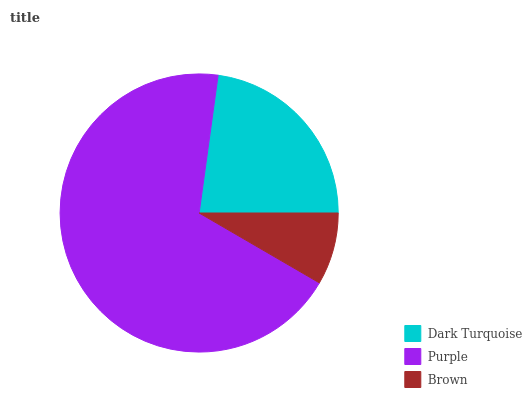Is Brown the minimum?
Answer yes or no. Yes. Is Purple the maximum?
Answer yes or no. Yes. Is Purple the minimum?
Answer yes or no. No. Is Brown the maximum?
Answer yes or no. No. Is Purple greater than Brown?
Answer yes or no. Yes. Is Brown less than Purple?
Answer yes or no. Yes. Is Brown greater than Purple?
Answer yes or no. No. Is Purple less than Brown?
Answer yes or no. No. Is Dark Turquoise the high median?
Answer yes or no. Yes. Is Dark Turquoise the low median?
Answer yes or no. Yes. Is Brown the high median?
Answer yes or no. No. Is Purple the low median?
Answer yes or no. No. 